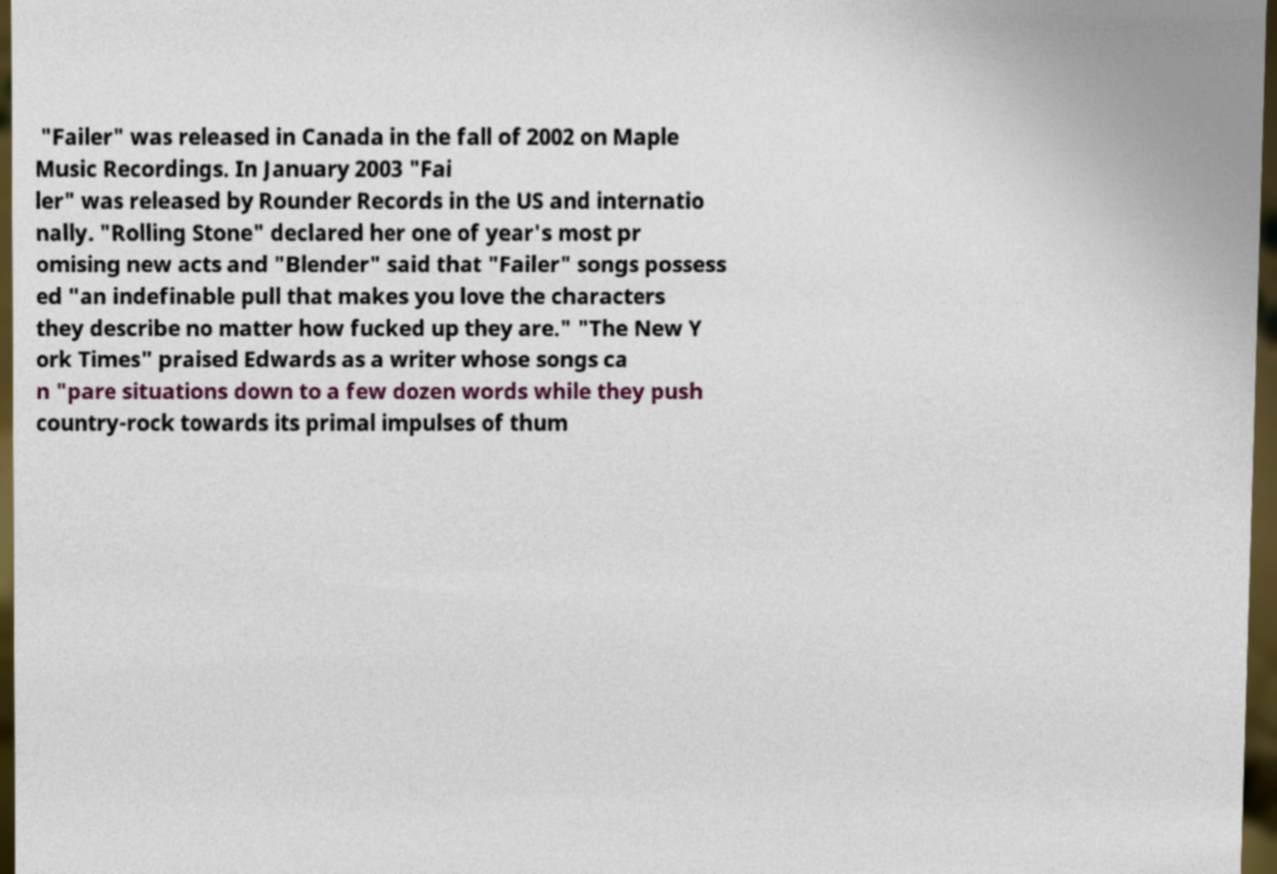I need the written content from this picture converted into text. Can you do that? "Failer" was released in Canada in the fall of 2002 on Maple Music Recordings. In January 2003 "Fai ler" was released by Rounder Records in the US and internatio nally. "Rolling Stone" declared her one of year's most pr omising new acts and "Blender" said that "Failer" songs possess ed "an indefinable pull that makes you love the characters they describe no matter how fucked up they are." "The New Y ork Times" praised Edwards as a writer whose songs ca n "pare situations down to a few dozen words while they push country-rock towards its primal impulses of thum 